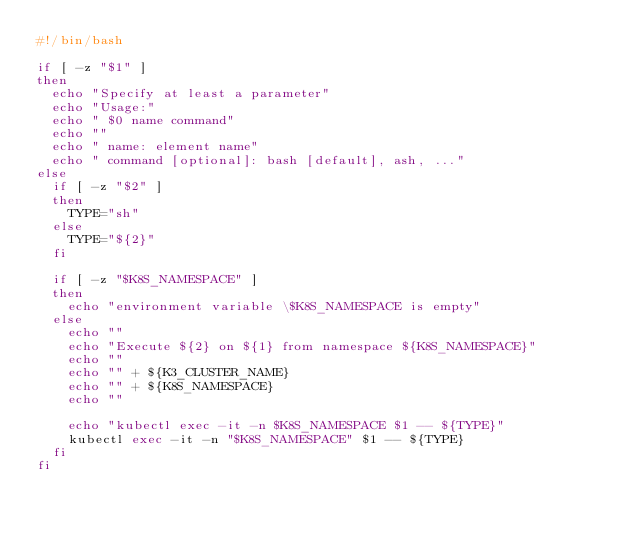<code> <loc_0><loc_0><loc_500><loc_500><_Bash_>#!/bin/bash

if [ -z "$1" ]
then
  echo "Specify at least a parameter"
  echo "Usage:"
  echo " $0 name command"
  echo ""
  echo " name: element name"
  echo " command [optional]: bash [default], ash, ..."
else
  if [ -z "$2" ]
  then
    TYPE="sh"
  else
    TYPE="${2}"
  fi

  if [ -z "$K8S_NAMESPACE" ]
  then
    echo "environment variable \$K8S_NAMESPACE is empty"
  else
    echo ""
    echo "Execute ${2} on ${1} from namespace ${K8S_NAMESPACE}"
    echo ""
    echo "" + ${K3_CLUSTER_NAME}
    echo "" + ${K8S_NAMESPACE}
    echo ""

    echo "kubectl exec -it -n $K8S_NAMESPACE $1 -- ${TYPE}"
    kubectl exec -it -n "$K8S_NAMESPACE" $1 -- ${TYPE}
  fi
fi
</code> 